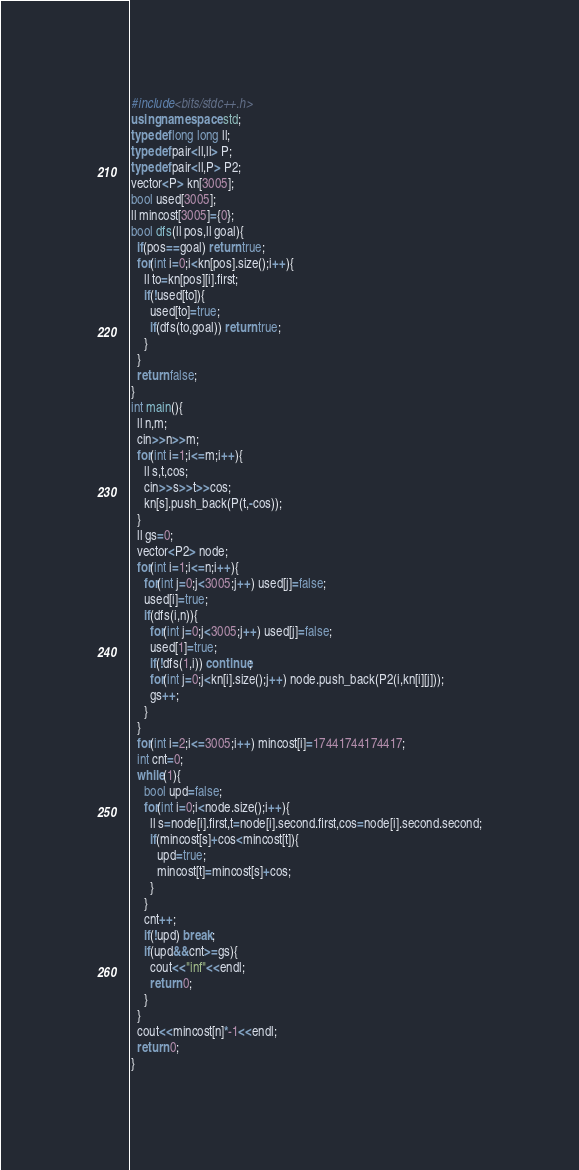Convert code to text. <code><loc_0><loc_0><loc_500><loc_500><_C++_>#include<bits/stdc++.h>
using namespace std;
typedef long long ll;
typedef pair<ll,ll> P;
typedef pair<ll,P> P2;
vector<P> kn[3005];
bool used[3005];
ll mincost[3005]={0};
bool dfs(ll pos,ll goal){
  if(pos==goal) return true;
  for(int i=0;i<kn[pos].size();i++){
    ll to=kn[pos][i].first;
    if(!used[to]){
      used[to]=true;
      if(dfs(to,goal)) return true;
    }
  }
  return false;
}
int main(){
  ll n,m;
  cin>>n>>m;
  for(int i=1;i<=m;i++){
    ll s,t,cos;
    cin>>s>>t>>cos;
    kn[s].push_back(P(t,-cos));
  }
  ll gs=0;
  vector<P2> node;
  for(int i=1;i<=n;i++){
    for(int j=0;j<3005;j++) used[j]=false;
    used[i]=true;
    if(dfs(i,n)){
      for(int j=0;j<3005;j++) used[j]=false;
      used[1]=true;
      if(!dfs(1,i)) continue;
      for(int j=0;j<kn[i].size();j++) node.push_back(P2(i,kn[i][j]));
      gs++;
    }
  }
  for(int i=2;i<=3005;i++) mincost[i]=17441744174417;
  int cnt=0;
  while(1){
    bool upd=false;
    for(int i=0;i<node.size();i++){
      ll s=node[i].first,t=node[i].second.first,cos=node[i].second.second;
      if(mincost[s]+cos<mincost[t]){
        upd=true;
        mincost[t]=mincost[s]+cos;
      }
    }
    cnt++;
    if(!upd) break;
    if(upd&&cnt>=gs){
      cout<<"inf"<<endl;
      return 0;
    }
  }
  cout<<mincost[n]*-1<<endl;
  return 0;
}
</code> 